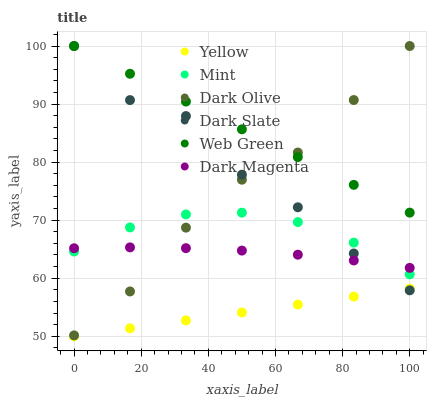Does Yellow have the minimum area under the curve?
Answer yes or no. Yes. Does Web Green have the maximum area under the curve?
Answer yes or no. Yes. Does Dark Olive have the minimum area under the curve?
Answer yes or no. No. Does Dark Olive have the maximum area under the curve?
Answer yes or no. No. Is Web Green the smoothest?
Answer yes or no. Yes. Is Dark Slate the roughest?
Answer yes or no. Yes. Is Dark Olive the smoothest?
Answer yes or no. No. Is Dark Olive the roughest?
Answer yes or no. No. Does Yellow have the lowest value?
Answer yes or no. Yes. Does Dark Olive have the lowest value?
Answer yes or no. No. Does Dark Slate have the highest value?
Answer yes or no. Yes. Does Yellow have the highest value?
Answer yes or no. No. Is Yellow less than Dark Olive?
Answer yes or no. Yes. Is Mint greater than Yellow?
Answer yes or no. Yes. Does Mint intersect Dark Slate?
Answer yes or no. Yes. Is Mint less than Dark Slate?
Answer yes or no. No. Is Mint greater than Dark Slate?
Answer yes or no. No. Does Yellow intersect Dark Olive?
Answer yes or no. No. 